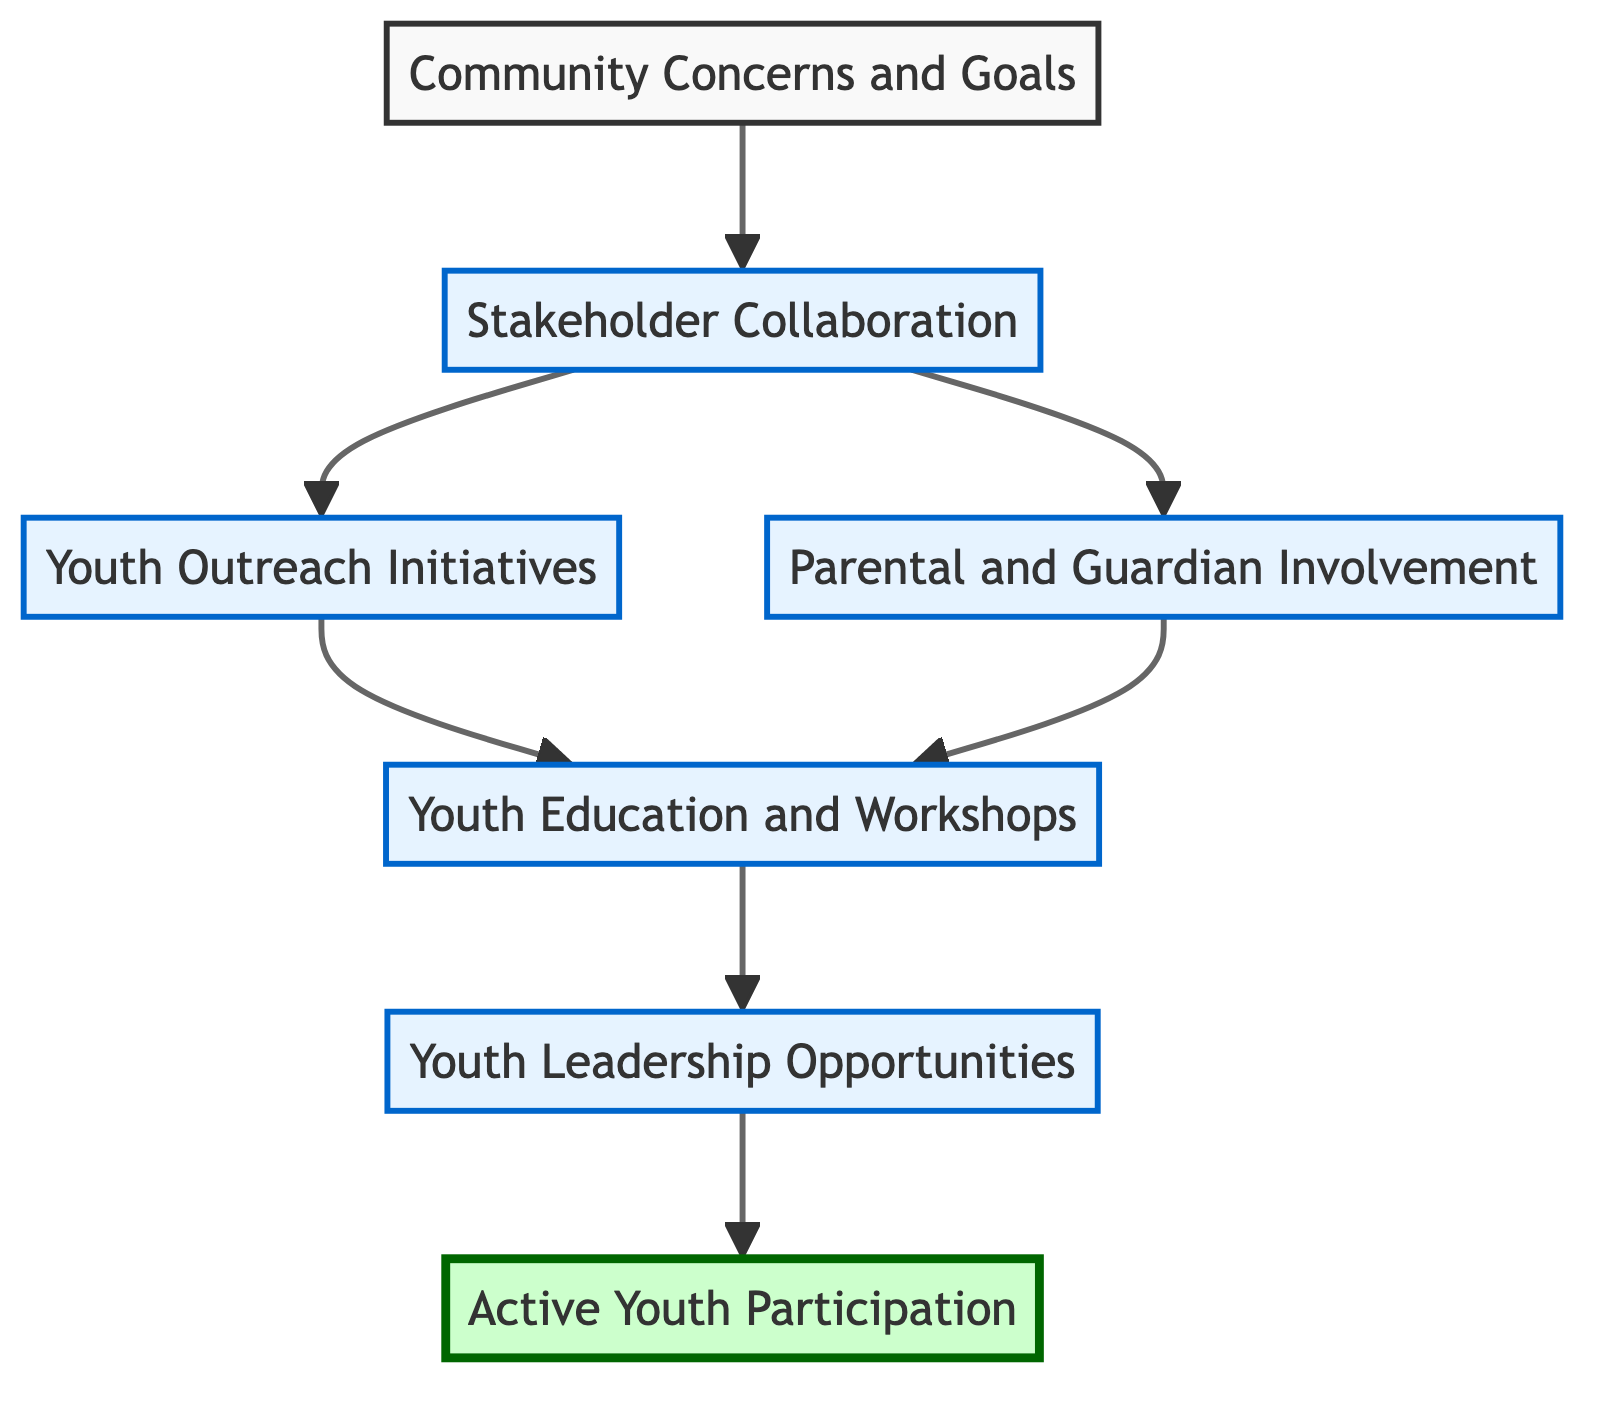What is the top element of the flow chart? The top element is "Active Youth Participation," which indicates the ultimate goal of the flow chart's initiatives.
Answer: Active Youth Participation How many nodes are in the flow chart? By counting all the elements in the flow chart, including the top element and all levels, we find there are seven nodes altogether.
Answer: 7 What comes directly after "Community Concerns and Goals"? The flow chart shows that "Stakeholder Collaboration" is the next step directly after identifying community concerns and goals.
Answer: Stakeholder Collaboration Which level includes "Youth Education and Workshops"? The node "Youth Education and Workshops" is found on level 3, as it follows after the outreach initiatives and parental involvement.
Answer: Level 3 Which two elements lead to "Youth Education and Workshops"? "Youth Outreach Initiatives" and "Parental and Guardian Involvement" both point to "Youth Education and Workshops," indicating they are prerequisites for this node.
Answer: Youth Outreach Initiatives and Parental and Guardian Involvement What is the final step in the flow chart? The last step in the flow chart leading from "Youth Leadership Opportunities" is "Active Youth Participation," which signifies the culmination of all prior efforts.
Answer: Active Youth Participation What type of involvement is encouraged from parents and guardians? The flow chart specifies "Parental and Guardian Involvement," suggesting they should actively engage in safety initiatives directed at youth.
Answer: Active role in safety initiatives What kind of opportunities are provided to youth at level 4? Level 4 presents "Youth Leadership Opportunities" that empower youth to take initiative in the community concerning safety.
Answer: Youth Leadership Opportunities Which node acts as a bridge between outreach initiatives and active youth participation? "Youth Leadership Opportunities" serves as a critical transition between the educational aspects of the programs and the overall goal of engaging youth actively.
Answer: Youth Leadership Opportunities 